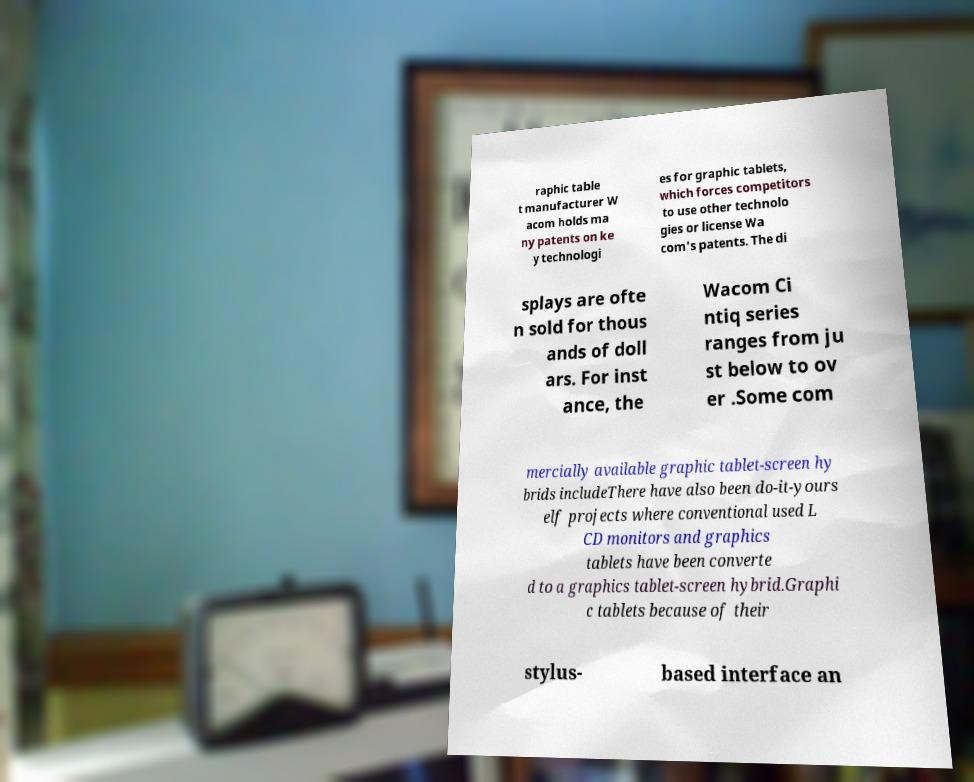There's text embedded in this image that I need extracted. Can you transcribe it verbatim? raphic table t manufacturer W acom holds ma ny patents on ke y technologi es for graphic tablets, which forces competitors to use other technolo gies or license Wa com's patents. The di splays are ofte n sold for thous ands of doll ars. For inst ance, the Wacom Ci ntiq series ranges from ju st below to ov er .Some com mercially available graphic tablet-screen hy brids includeThere have also been do-it-yours elf projects where conventional used L CD monitors and graphics tablets have been converte d to a graphics tablet-screen hybrid.Graphi c tablets because of their stylus- based interface an 